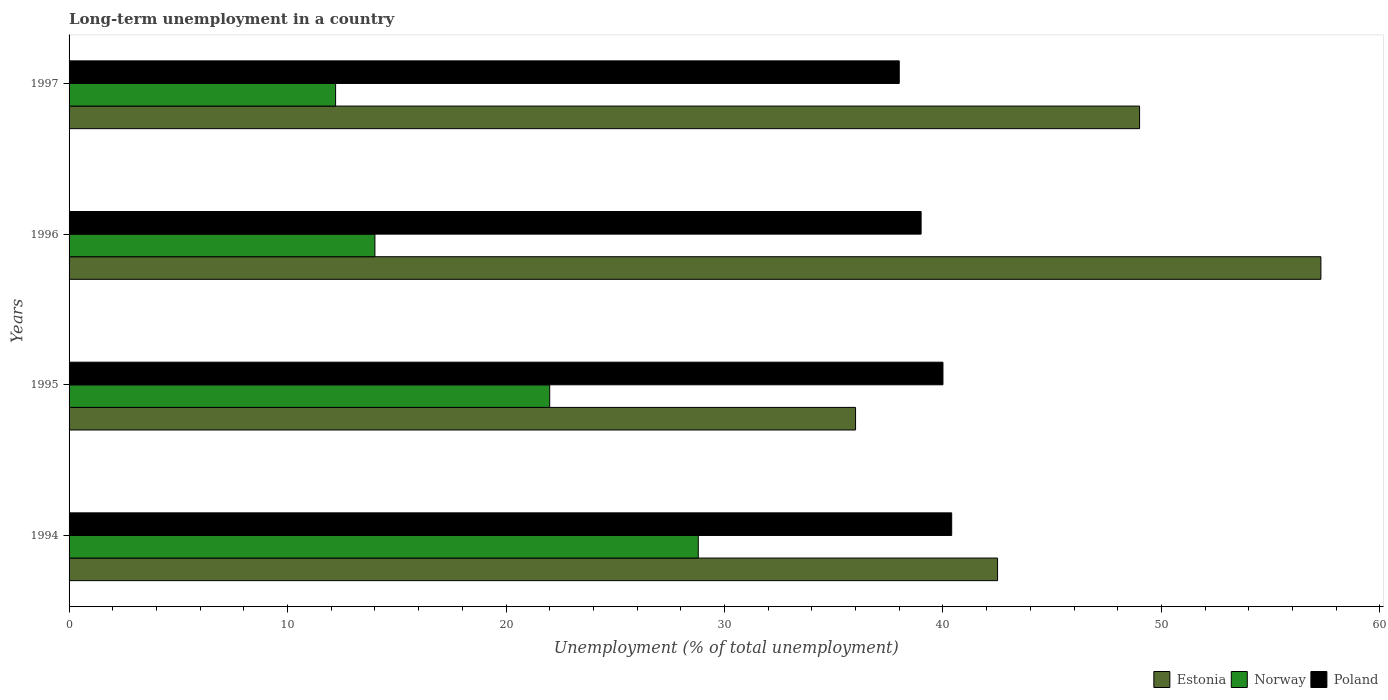Are the number of bars per tick equal to the number of legend labels?
Give a very brief answer. Yes. Are the number of bars on each tick of the Y-axis equal?
Your answer should be compact. Yes. How many bars are there on the 2nd tick from the top?
Keep it short and to the point. 3. How many bars are there on the 4th tick from the bottom?
Your response must be concise. 3. What is the label of the 1st group of bars from the top?
Ensure brevity in your answer.  1997. Across all years, what is the maximum percentage of long-term unemployed population in Poland?
Offer a terse response. 40.4. In which year was the percentage of long-term unemployed population in Norway minimum?
Your response must be concise. 1997. What is the total percentage of long-term unemployed population in Norway in the graph?
Offer a very short reply. 77. What is the difference between the percentage of long-term unemployed population in Estonia in 1996 and the percentage of long-term unemployed population in Poland in 1997?
Your response must be concise. 19.3. What is the average percentage of long-term unemployed population in Poland per year?
Provide a short and direct response. 39.35. In the year 1995, what is the difference between the percentage of long-term unemployed population in Poland and percentage of long-term unemployed population in Norway?
Provide a short and direct response. 18. In how many years, is the percentage of long-term unemployed population in Norway greater than 4 %?
Ensure brevity in your answer.  4. What is the ratio of the percentage of long-term unemployed population in Norway in 1995 to that in 1997?
Your answer should be compact. 1.8. Is the difference between the percentage of long-term unemployed population in Poland in 1994 and 1996 greater than the difference between the percentage of long-term unemployed population in Norway in 1994 and 1996?
Your answer should be compact. No. What is the difference between the highest and the second highest percentage of long-term unemployed population in Norway?
Give a very brief answer. 6.8. What is the difference between the highest and the lowest percentage of long-term unemployed population in Estonia?
Provide a succinct answer. 21.3. Is the sum of the percentage of long-term unemployed population in Norway in 1996 and 1997 greater than the maximum percentage of long-term unemployed population in Estonia across all years?
Provide a succinct answer. No. What does the 3rd bar from the top in 1997 represents?
Your response must be concise. Estonia. What does the 1st bar from the bottom in 1995 represents?
Your answer should be very brief. Estonia. Are all the bars in the graph horizontal?
Give a very brief answer. Yes. How many years are there in the graph?
Your answer should be very brief. 4. Does the graph contain any zero values?
Your answer should be very brief. No. Does the graph contain grids?
Ensure brevity in your answer.  No. How many legend labels are there?
Your answer should be compact. 3. How are the legend labels stacked?
Your answer should be very brief. Horizontal. What is the title of the graph?
Your answer should be very brief. Long-term unemployment in a country. Does "Tunisia" appear as one of the legend labels in the graph?
Keep it short and to the point. No. What is the label or title of the X-axis?
Provide a succinct answer. Unemployment (% of total unemployment). What is the Unemployment (% of total unemployment) in Estonia in 1994?
Provide a short and direct response. 42.5. What is the Unemployment (% of total unemployment) in Norway in 1994?
Offer a very short reply. 28.8. What is the Unemployment (% of total unemployment) in Poland in 1994?
Provide a short and direct response. 40.4. What is the Unemployment (% of total unemployment) in Norway in 1995?
Keep it short and to the point. 22. What is the Unemployment (% of total unemployment) in Estonia in 1996?
Provide a succinct answer. 57.3. What is the Unemployment (% of total unemployment) of Poland in 1996?
Ensure brevity in your answer.  39. What is the Unemployment (% of total unemployment) of Norway in 1997?
Your answer should be very brief. 12.2. What is the Unemployment (% of total unemployment) of Poland in 1997?
Provide a succinct answer. 38. Across all years, what is the maximum Unemployment (% of total unemployment) of Estonia?
Provide a short and direct response. 57.3. Across all years, what is the maximum Unemployment (% of total unemployment) of Norway?
Your answer should be compact. 28.8. Across all years, what is the maximum Unemployment (% of total unemployment) of Poland?
Provide a short and direct response. 40.4. Across all years, what is the minimum Unemployment (% of total unemployment) in Estonia?
Provide a short and direct response. 36. Across all years, what is the minimum Unemployment (% of total unemployment) of Norway?
Your answer should be compact. 12.2. What is the total Unemployment (% of total unemployment) in Estonia in the graph?
Keep it short and to the point. 184.8. What is the total Unemployment (% of total unemployment) in Poland in the graph?
Make the answer very short. 157.4. What is the difference between the Unemployment (% of total unemployment) in Estonia in 1994 and that in 1995?
Ensure brevity in your answer.  6.5. What is the difference between the Unemployment (% of total unemployment) of Norway in 1994 and that in 1995?
Your answer should be compact. 6.8. What is the difference between the Unemployment (% of total unemployment) in Poland in 1994 and that in 1995?
Provide a succinct answer. 0.4. What is the difference between the Unemployment (% of total unemployment) of Estonia in 1994 and that in 1996?
Give a very brief answer. -14.8. What is the difference between the Unemployment (% of total unemployment) in Norway in 1994 and that in 1997?
Your answer should be compact. 16.6. What is the difference between the Unemployment (% of total unemployment) in Estonia in 1995 and that in 1996?
Provide a succinct answer. -21.3. What is the difference between the Unemployment (% of total unemployment) of Estonia in 1995 and that in 1997?
Your answer should be compact. -13. What is the difference between the Unemployment (% of total unemployment) of Estonia in 1994 and the Unemployment (% of total unemployment) of Poland in 1995?
Provide a succinct answer. 2.5. What is the difference between the Unemployment (% of total unemployment) of Estonia in 1994 and the Unemployment (% of total unemployment) of Poland in 1996?
Give a very brief answer. 3.5. What is the difference between the Unemployment (% of total unemployment) of Estonia in 1994 and the Unemployment (% of total unemployment) of Norway in 1997?
Ensure brevity in your answer.  30.3. What is the difference between the Unemployment (% of total unemployment) of Norway in 1994 and the Unemployment (% of total unemployment) of Poland in 1997?
Your answer should be compact. -9.2. What is the difference between the Unemployment (% of total unemployment) of Estonia in 1995 and the Unemployment (% of total unemployment) of Poland in 1996?
Keep it short and to the point. -3. What is the difference between the Unemployment (% of total unemployment) in Norway in 1995 and the Unemployment (% of total unemployment) in Poland in 1996?
Ensure brevity in your answer.  -17. What is the difference between the Unemployment (% of total unemployment) in Estonia in 1995 and the Unemployment (% of total unemployment) in Norway in 1997?
Your answer should be very brief. 23.8. What is the difference between the Unemployment (% of total unemployment) in Estonia in 1996 and the Unemployment (% of total unemployment) in Norway in 1997?
Offer a very short reply. 45.1. What is the difference between the Unemployment (% of total unemployment) in Estonia in 1996 and the Unemployment (% of total unemployment) in Poland in 1997?
Your answer should be very brief. 19.3. What is the difference between the Unemployment (% of total unemployment) in Norway in 1996 and the Unemployment (% of total unemployment) in Poland in 1997?
Offer a terse response. -24. What is the average Unemployment (% of total unemployment) of Estonia per year?
Your answer should be very brief. 46.2. What is the average Unemployment (% of total unemployment) in Norway per year?
Your response must be concise. 19.25. What is the average Unemployment (% of total unemployment) of Poland per year?
Make the answer very short. 39.35. In the year 1994, what is the difference between the Unemployment (% of total unemployment) in Estonia and Unemployment (% of total unemployment) in Norway?
Ensure brevity in your answer.  13.7. In the year 1994, what is the difference between the Unemployment (% of total unemployment) in Norway and Unemployment (% of total unemployment) in Poland?
Keep it short and to the point. -11.6. In the year 1995, what is the difference between the Unemployment (% of total unemployment) in Norway and Unemployment (% of total unemployment) in Poland?
Offer a terse response. -18. In the year 1996, what is the difference between the Unemployment (% of total unemployment) of Estonia and Unemployment (% of total unemployment) of Norway?
Provide a succinct answer. 43.3. In the year 1996, what is the difference between the Unemployment (% of total unemployment) of Norway and Unemployment (% of total unemployment) of Poland?
Offer a very short reply. -25. In the year 1997, what is the difference between the Unemployment (% of total unemployment) in Estonia and Unemployment (% of total unemployment) in Norway?
Offer a very short reply. 36.8. In the year 1997, what is the difference between the Unemployment (% of total unemployment) of Estonia and Unemployment (% of total unemployment) of Poland?
Keep it short and to the point. 11. In the year 1997, what is the difference between the Unemployment (% of total unemployment) of Norway and Unemployment (% of total unemployment) of Poland?
Make the answer very short. -25.8. What is the ratio of the Unemployment (% of total unemployment) of Estonia in 1994 to that in 1995?
Provide a succinct answer. 1.18. What is the ratio of the Unemployment (% of total unemployment) in Norway in 1994 to that in 1995?
Provide a short and direct response. 1.31. What is the ratio of the Unemployment (% of total unemployment) of Poland in 1994 to that in 1995?
Your answer should be very brief. 1.01. What is the ratio of the Unemployment (% of total unemployment) in Estonia in 1994 to that in 1996?
Keep it short and to the point. 0.74. What is the ratio of the Unemployment (% of total unemployment) of Norway in 1994 to that in 1996?
Keep it short and to the point. 2.06. What is the ratio of the Unemployment (% of total unemployment) of Poland in 1994 to that in 1996?
Provide a short and direct response. 1.04. What is the ratio of the Unemployment (% of total unemployment) in Estonia in 1994 to that in 1997?
Give a very brief answer. 0.87. What is the ratio of the Unemployment (% of total unemployment) of Norway in 1994 to that in 1997?
Make the answer very short. 2.36. What is the ratio of the Unemployment (% of total unemployment) of Poland in 1994 to that in 1997?
Your answer should be very brief. 1.06. What is the ratio of the Unemployment (% of total unemployment) in Estonia in 1995 to that in 1996?
Offer a very short reply. 0.63. What is the ratio of the Unemployment (% of total unemployment) of Norway in 1995 to that in 1996?
Provide a short and direct response. 1.57. What is the ratio of the Unemployment (% of total unemployment) in Poland in 1995 to that in 1996?
Your answer should be very brief. 1.03. What is the ratio of the Unemployment (% of total unemployment) in Estonia in 1995 to that in 1997?
Your response must be concise. 0.73. What is the ratio of the Unemployment (% of total unemployment) of Norway in 1995 to that in 1997?
Give a very brief answer. 1.8. What is the ratio of the Unemployment (% of total unemployment) in Poland in 1995 to that in 1997?
Provide a short and direct response. 1.05. What is the ratio of the Unemployment (% of total unemployment) in Estonia in 1996 to that in 1997?
Your answer should be compact. 1.17. What is the ratio of the Unemployment (% of total unemployment) of Norway in 1996 to that in 1997?
Your response must be concise. 1.15. What is the ratio of the Unemployment (% of total unemployment) in Poland in 1996 to that in 1997?
Provide a succinct answer. 1.03. What is the difference between the highest and the second highest Unemployment (% of total unemployment) of Estonia?
Your answer should be compact. 8.3. What is the difference between the highest and the second highest Unemployment (% of total unemployment) of Poland?
Ensure brevity in your answer.  0.4. What is the difference between the highest and the lowest Unemployment (% of total unemployment) in Estonia?
Your response must be concise. 21.3. What is the difference between the highest and the lowest Unemployment (% of total unemployment) in Norway?
Your answer should be very brief. 16.6. What is the difference between the highest and the lowest Unemployment (% of total unemployment) in Poland?
Make the answer very short. 2.4. 